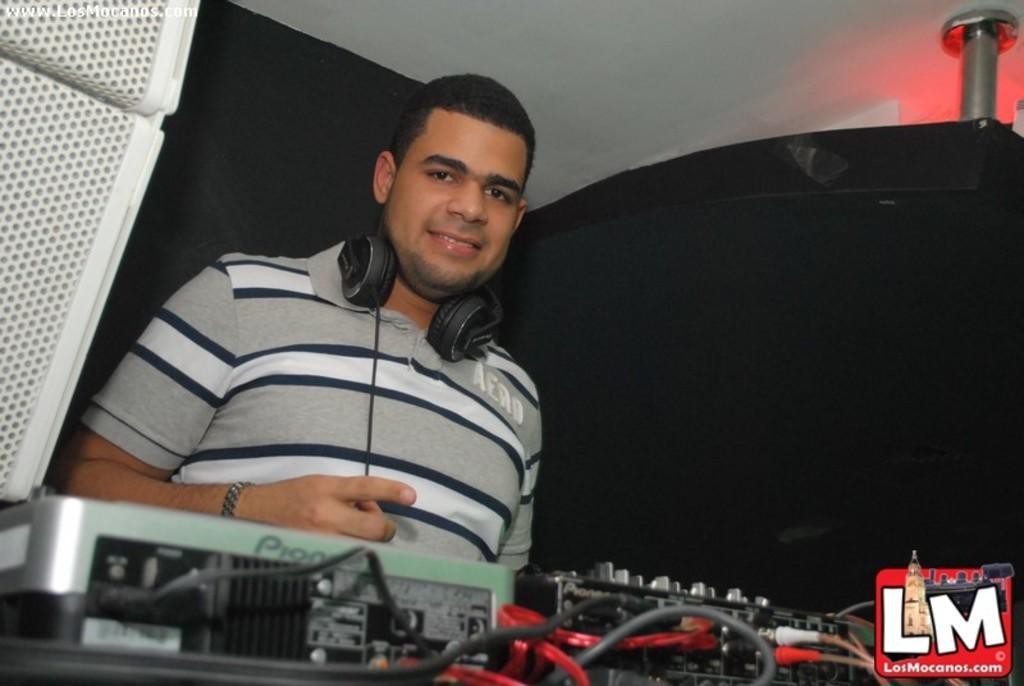Please provide a concise description of this image. A man is there, he wore headset, t-shirt. He is smiling. 